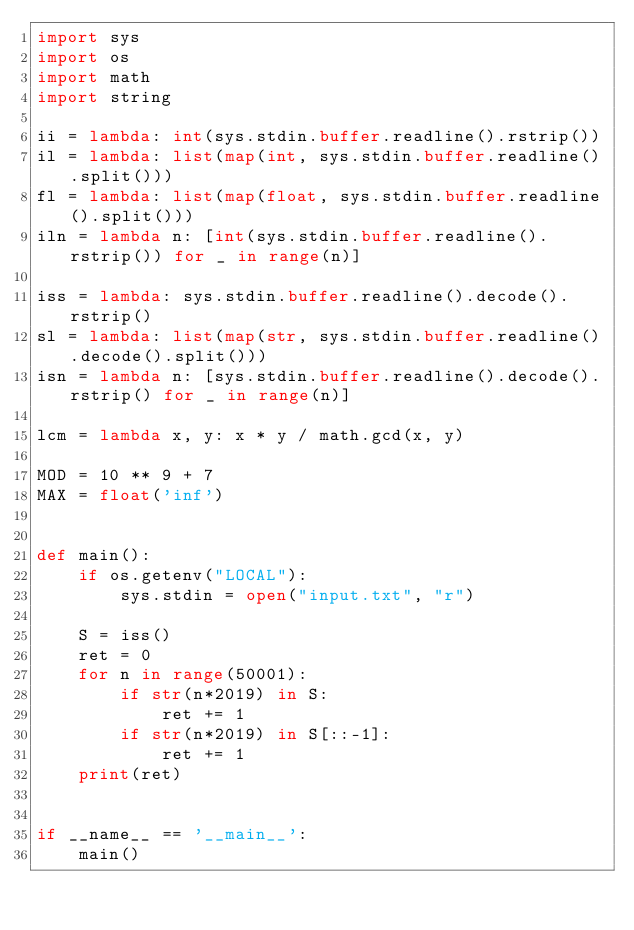Convert code to text. <code><loc_0><loc_0><loc_500><loc_500><_Python_>import sys
import os
import math
import string

ii = lambda: int(sys.stdin.buffer.readline().rstrip())
il = lambda: list(map(int, sys.stdin.buffer.readline().split()))
fl = lambda: list(map(float, sys.stdin.buffer.readline().split()))
iln = lambda n: [int(sys.stdin.buffer.readline().rstrip()) for _ in range(n)]

iss = lambda: sys.stdin.buffer.readline().decode().rstrip()
sl = lambda: list(map(str, sys.stdin.buffer.readline().decode().split()))
isn = lambda n: [sys.stdin.buffer.readline().decode().rstrip() for _ in range(n)]

lcm = lambda x, y: x * y / math.gcd(x, y)

MOD = 10 ** 9 + 7
MAX = float('inf')


def main():
    if os.getenv("LOCAL"):
        sys.stdin = open("input.txt", "r")

    S = iss()
    ret = 0
    for n in range(50001):
        if str(n*2019) in S:
            ret += 1
        if str(n*2019) in S[::-1]:
            ret += 1
    print(ret)


if __name__ == '__main__':
    main()
</code> 